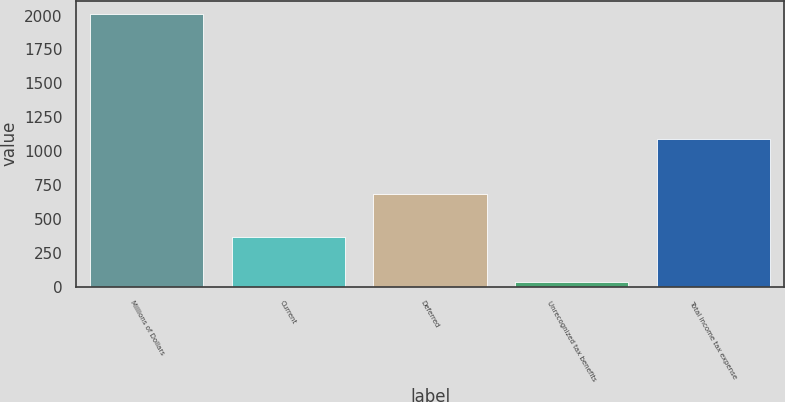<chart> <loc_0><loc_0><loc_500><loc_500><bar_chart><fcel>Millions of Dollars<fcel>Current<fcel>Deferred<fcel>Unrecognized tax benefits<fcel>Total income tax expense<nl><fcel>2009<fcel>366<fcel>685<fcel>38<fcel>1089<nl></chart> 